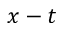<formula> <loc_0><loc_0><loc_500><loc_500>x - t</formula> 